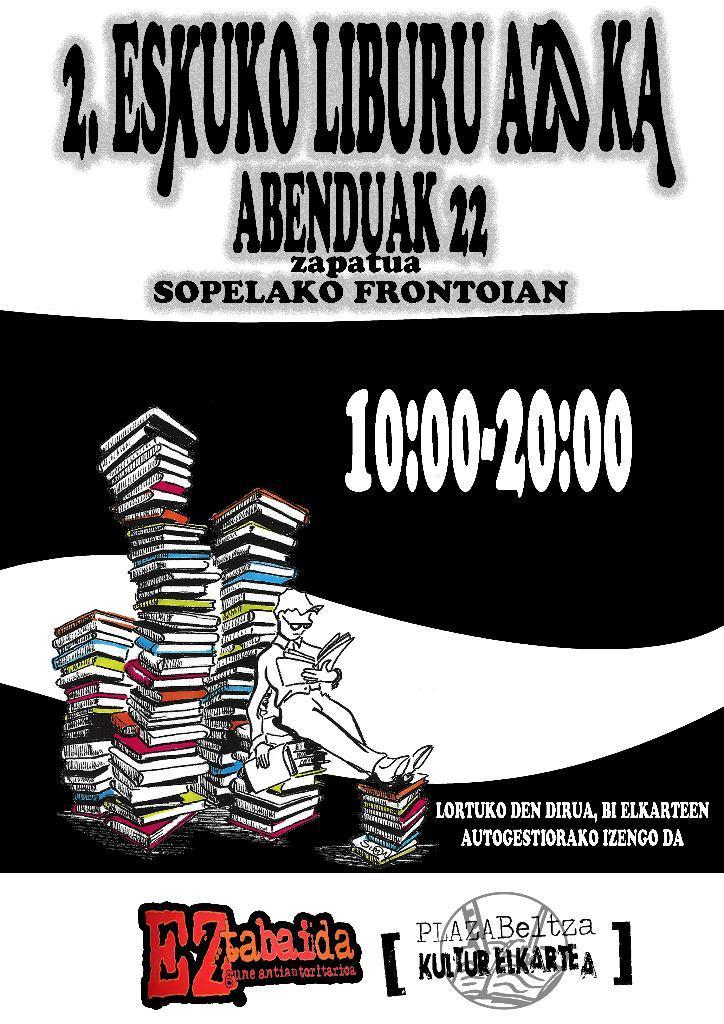Could you give a brief overview of what you see in this image? In this image we can see a graphical picture of a person holding a book in his hand, a group of books and some text on it. 